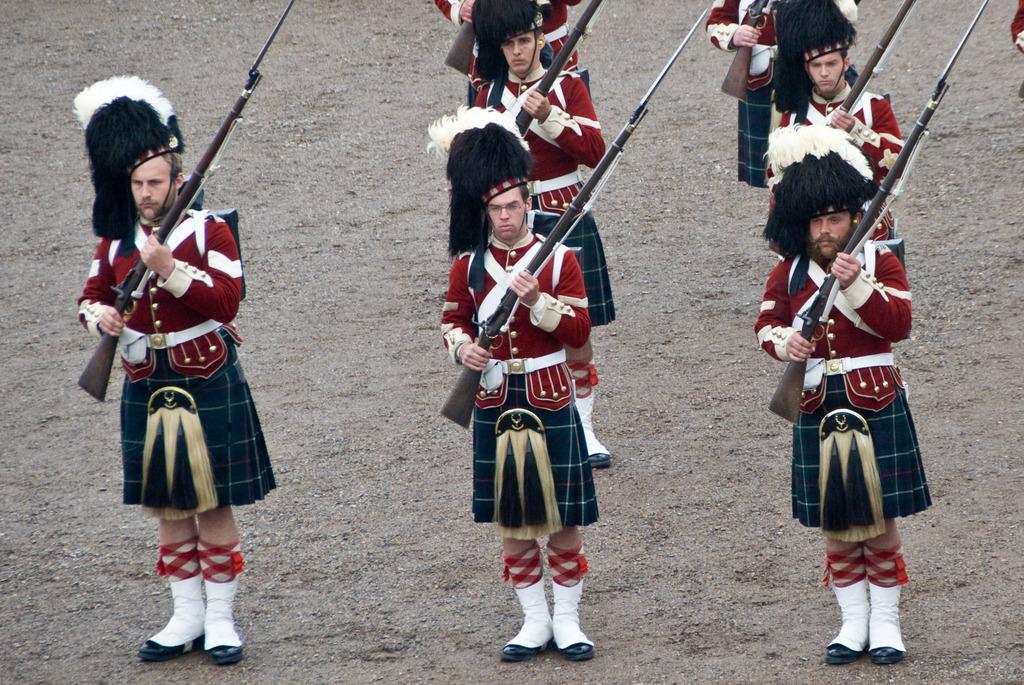Who or what is present in the image? There are people in the image. What are the people doing in the image? The people are standing and holding rifles. What type of surface is visible at the bottom of the image? There is soil visible at the bottom of the image. What type of power can be seen emanating from the people in the image? There is no indication of power emanating from the people in the image; they are simply standing and holding rifles. 